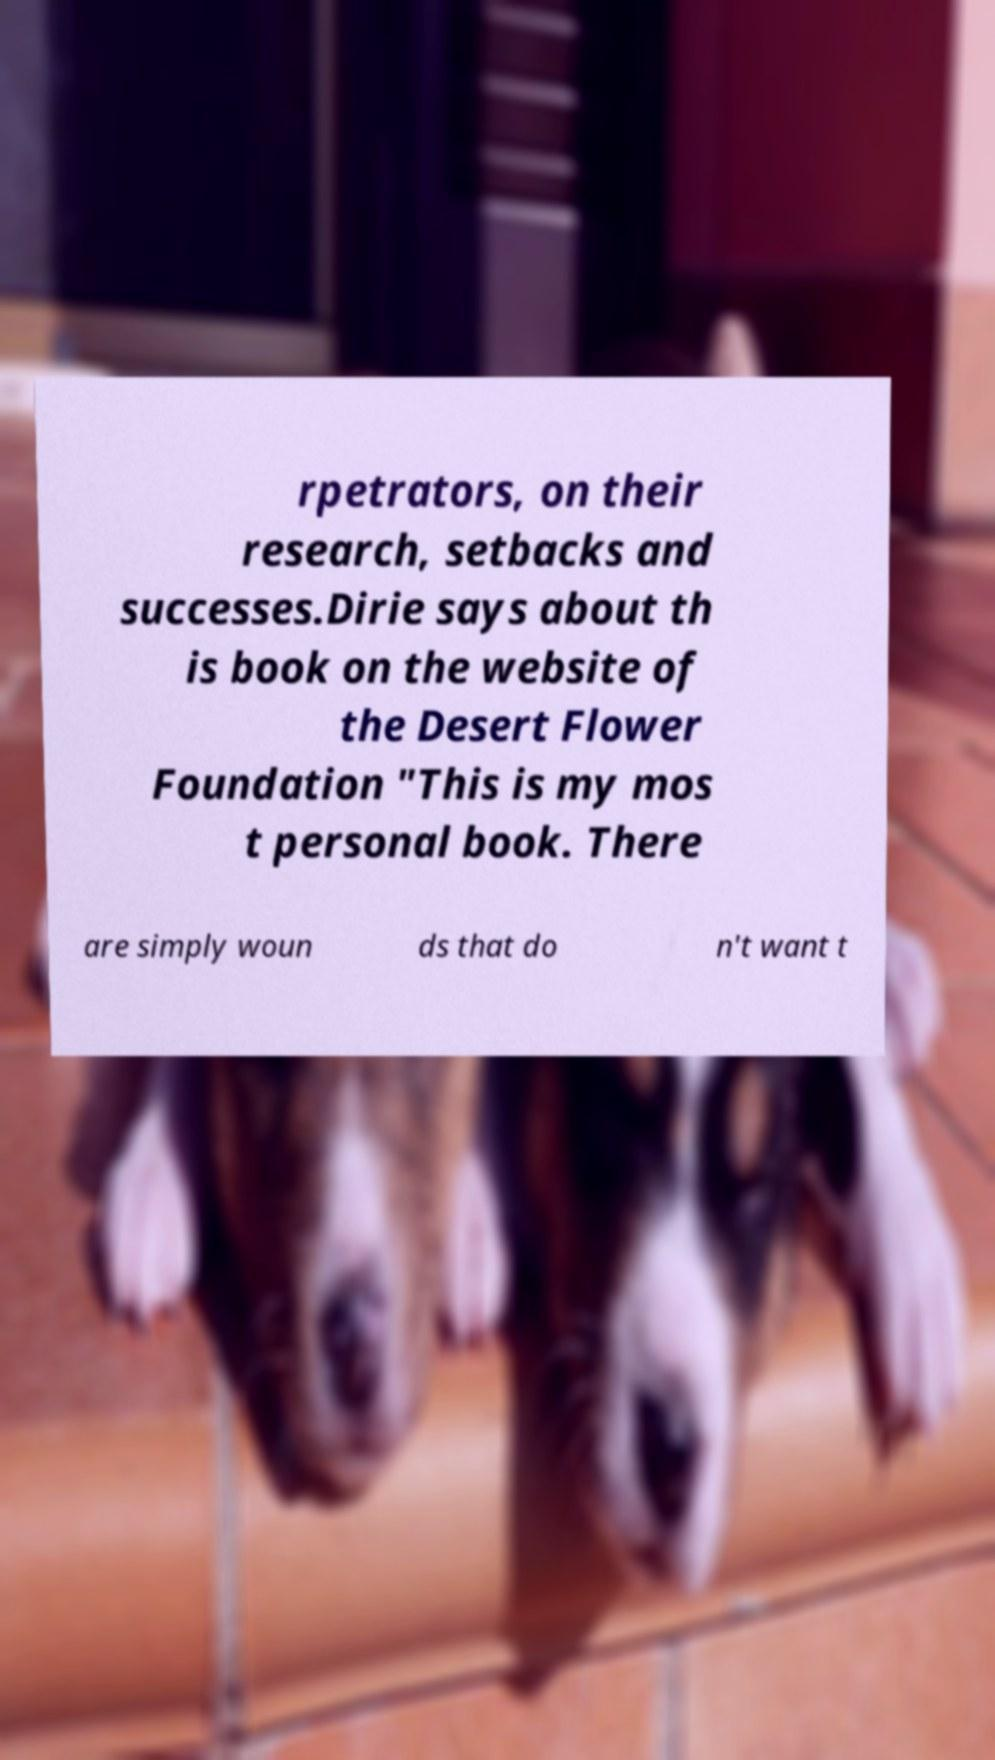There's text embedded in this image that I need extracted. Can you transcribe it verbatim? rpetrators, on their research, setbacks and successes.Dirie says about th is book on the website of the Desert Flower Foundation "This is my mos t personal book. There are simply woun ds that do n't want t 